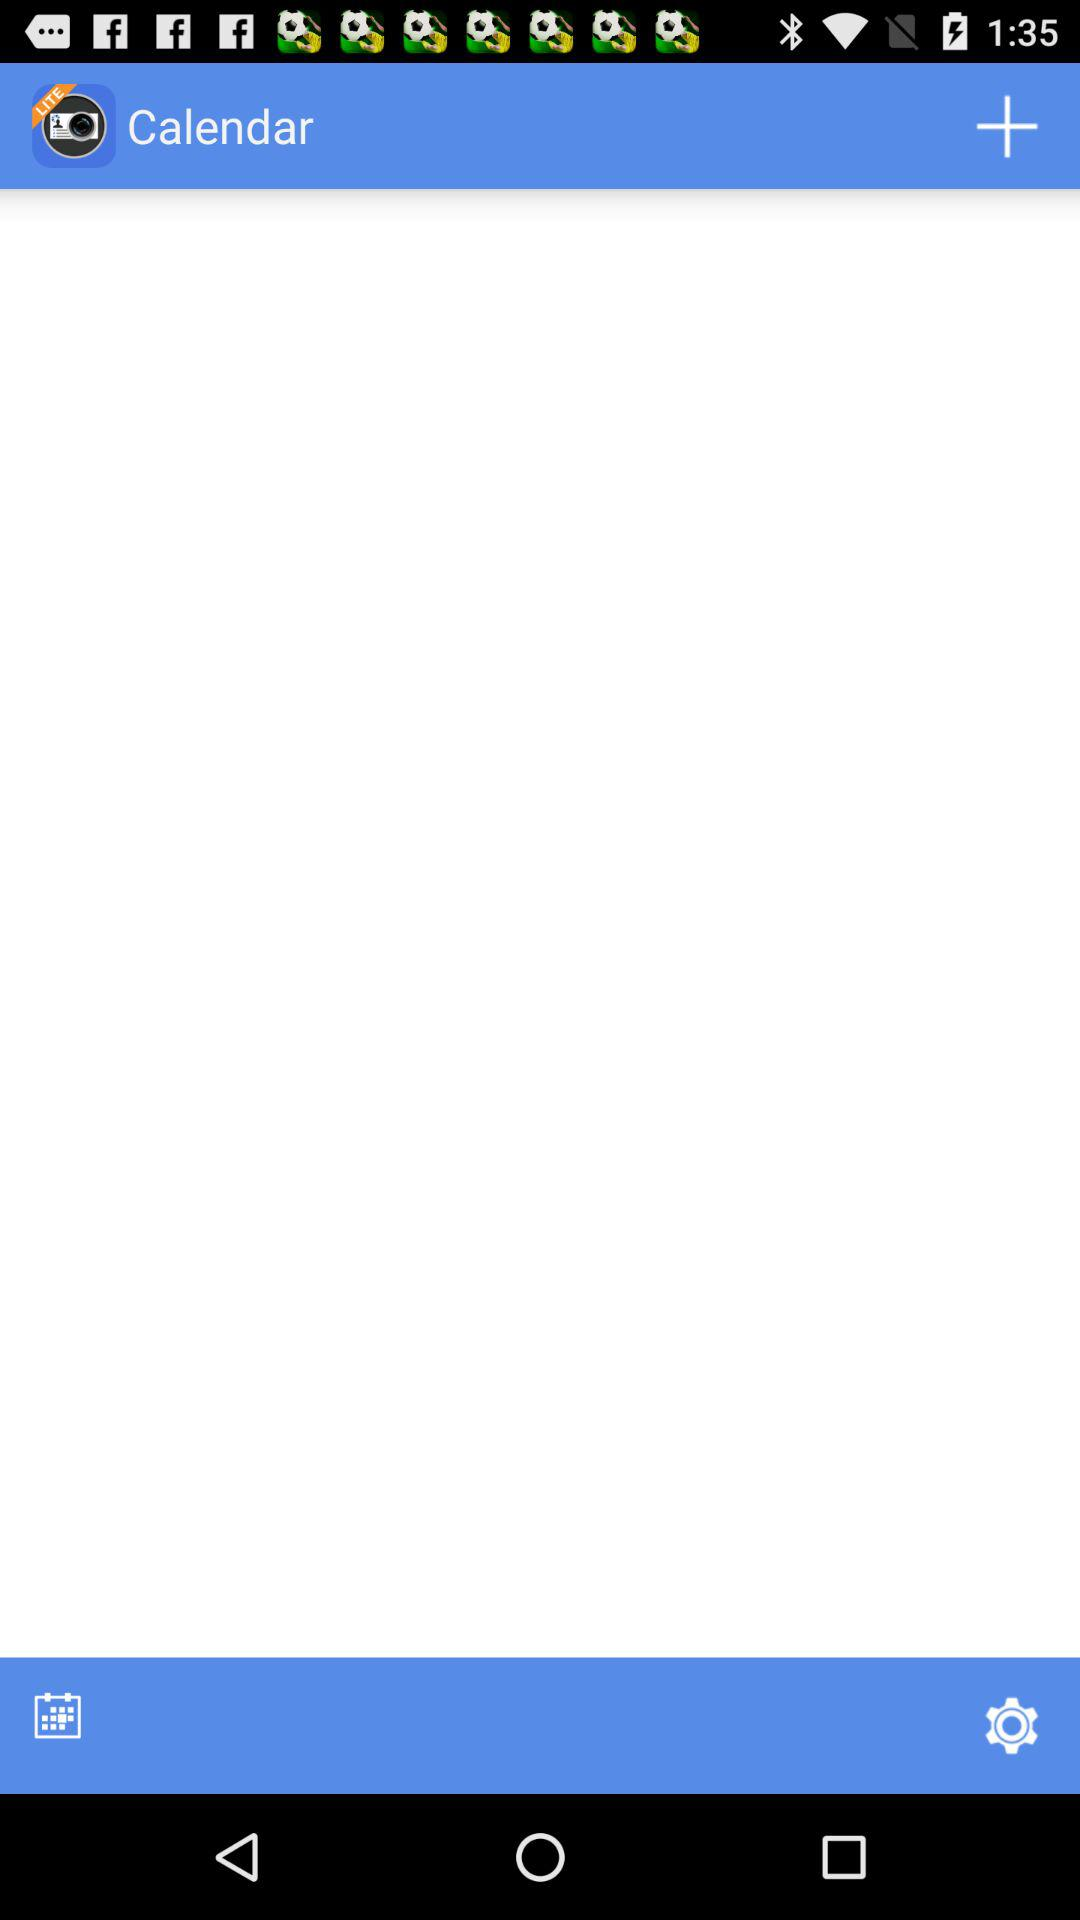What is the application name? The application name is "ScanBizCards Lite". 